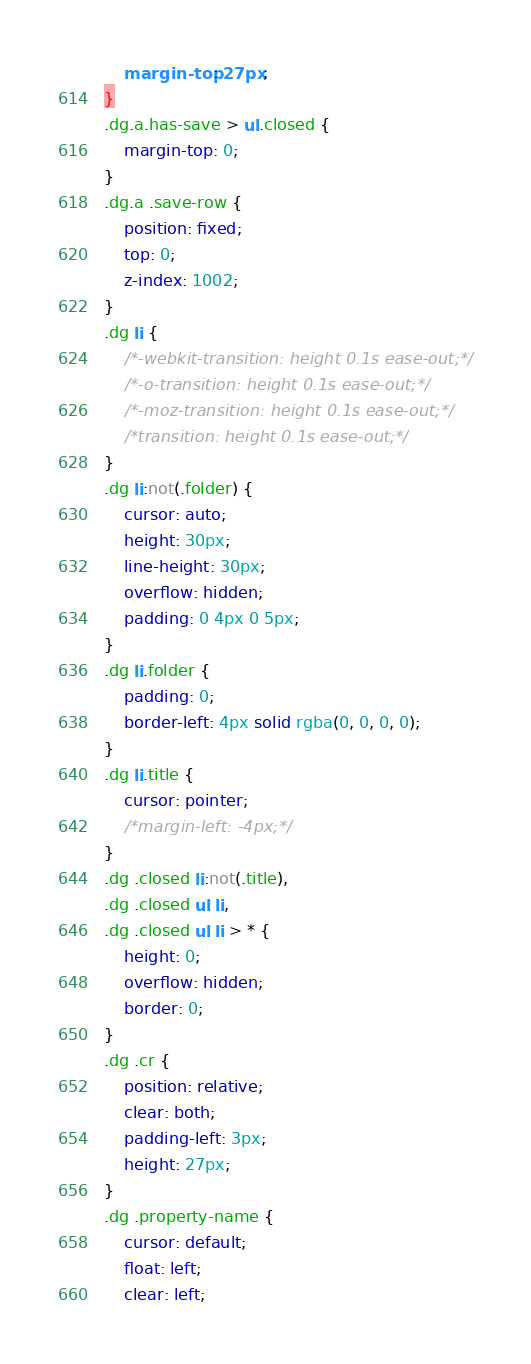<code> <loc_0><loc_0><loc_500><loc_500><_CSS_>    margin-top: 27px;
}
.dg.a.has-save > ul.closed {
    margin-top: 0;
}
.dg.a .save-row {
    position: fixed;
    top: 0;
    z-index: 1002;
}
.dg li {
    /*-webkit-transition: height 0.1s ease-out;*/
    /*-o-transition: height 0.1s ease-out;*/
    /*-moz-transition: height 0.1s ease-out;*/
    /*transition: height 0.1s ease-out;*/
}
.dg li:not(.folder) {
    cursor: auto;
    height: 30px;
    line-height: 30px;
    overflow: hidden;
    padding: 0 4px 0 5px;
}
.dg li.folder {
    padding: 0;
    border-left: 4px solid rgba(0, 0, 0, 0);
}
.dg li.title {
    cursor: pointer;
    /*margin-left: -4px;*/
}
.dg .closed li:not(.title),
.dg .closed ul li,
.dg .closed ul li > * {
    height: 0;
    overflow: hidden;
    border: 0;
}
.dg .cr {
    position: relative;
    clear: both;
    padding-left: 3px;
    height: 27px;
}
.dg .property-name {
    cursor: default;
    float: left;
    clear: left;</code> 